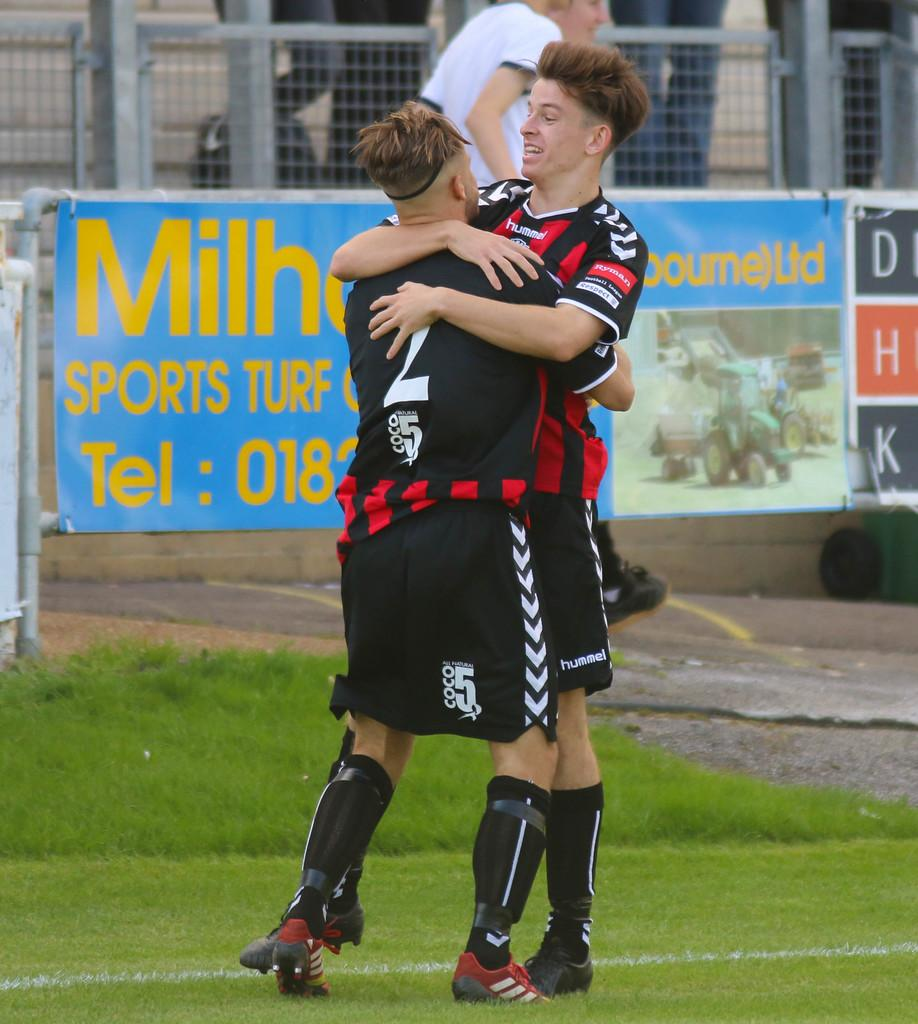<image>
Create a compact narrative representing the image presented. Two soccer players hug each other in front of an ad for a Sports Turf business. 